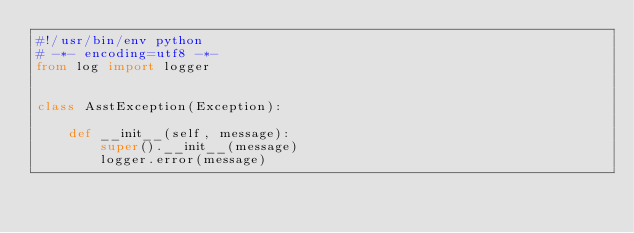Convert code to text. <code><loc_0><loc_0><loc_500><loc_500><_Python_>#!/usr/bin/env python
# -*- encoding=utf8 -*-
from log import logger


class AsstException(Exception):

    def __init__(self, message):
        super().__init__(message)
        logger.error(message)
</code> 